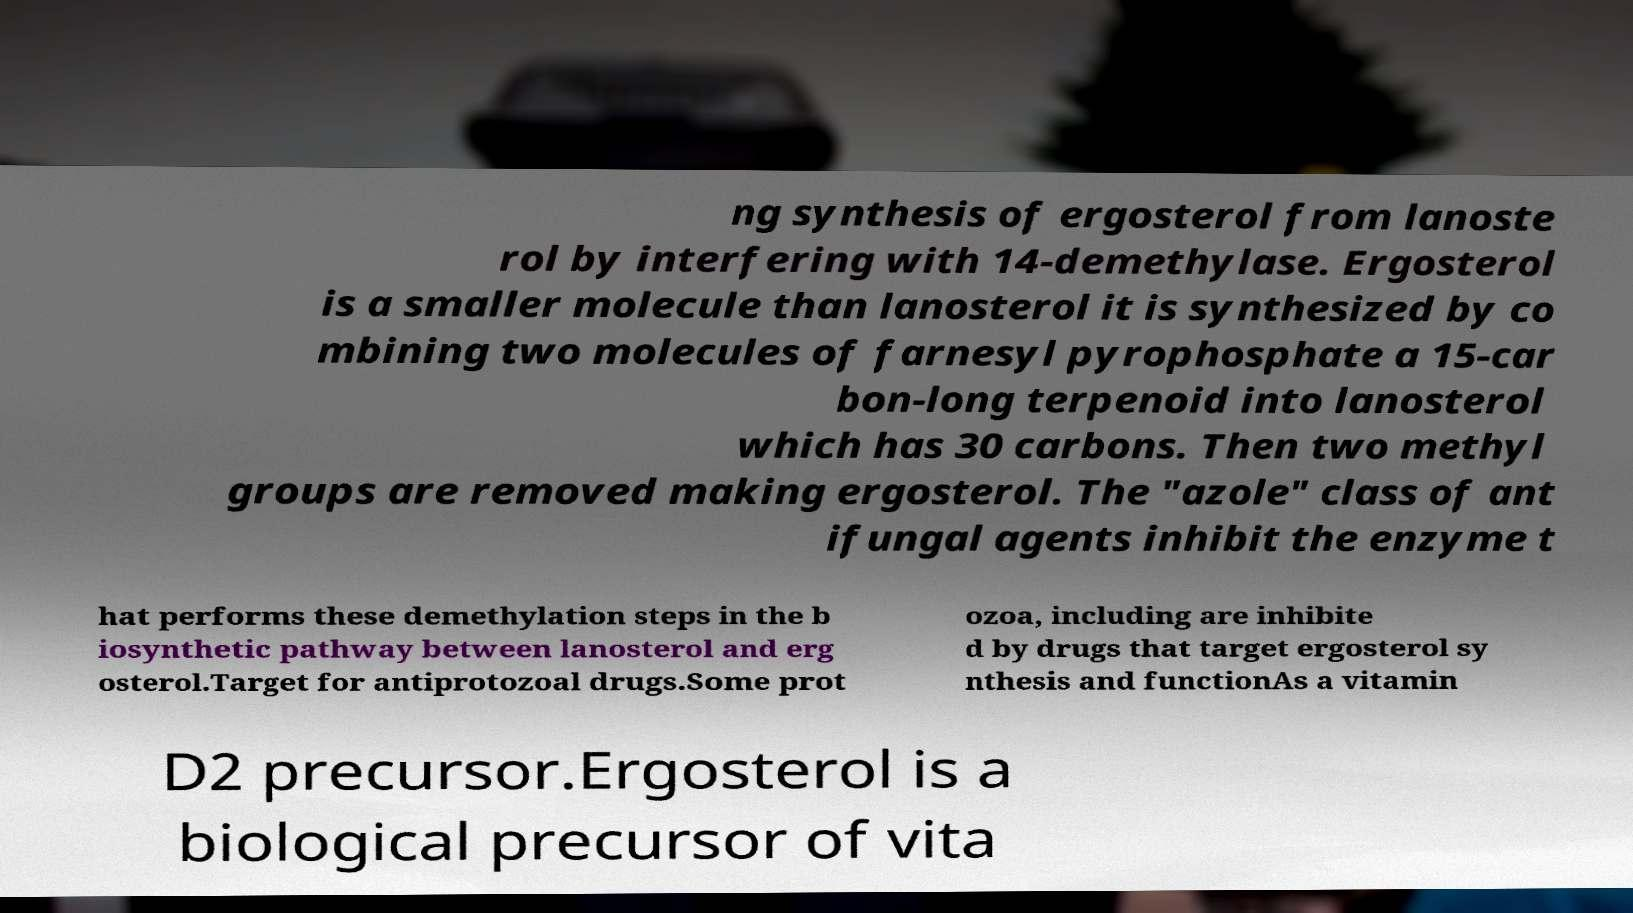Please identify and transcribe the text found in this image. ng synthesis of ergosterol from lanoste rol by interfering with 14-demethylase. Ergosterol is a smaller molecule than lanosterol it is synthesized by co mbining two molecules of farnesyl pyrophosphate a 15-car bon-long terpenoid into lanosterol which has 30 carbons. Then two methyl groups are removed making ergosterol. The "azole" class of ant ifungal agents inhibit the enzyme t hat performs these demethylation steps in the b iosynthetic pathway between lanosterol and erg osterol.Target for antiprotozoal drugs.Some prot ozoa, including are inhibite d by drugs that target ergosterol sy nthesis and functionAs a vitamin D2 precursor.Ergosterol is a biological precursor of vita 